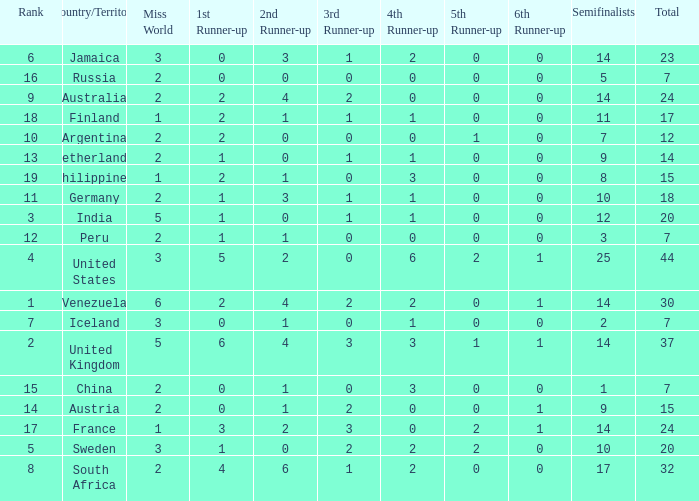What is Venezuela's total rank? 30.0. 